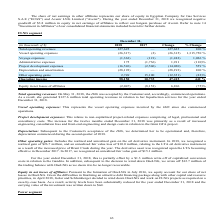According to Golar Lng's financial document, Why did the activity levels decrease in 2018? Golar and Schlumberger decided to wind down OneLNG and work on FLNG projects as required on a case-by-case basis. The document states: "r capital and resource priorities, in April 2018, Golar and Schlumberger decided to wind down OneLNG and work on FLNG projects as required on a case-b..." Also, What was the realized gain on the oil derivative instrument? According to the financial document, $26.7 million. The relevant text states: "trument. In 2018, we recognized a realized gain of $26.7 million, and an unrealized fair value loss of $10.0 million, relating to the LTA oil derivative instrument..." Also, What are the different components of expenses? The document contains multiple relevant values: Vessel operating expenses, Voyage expenses, Administrative expenses, Project development expenses, Depreciation and amortization. From the document: "rating expenses (26,317) (2) (26,315) 1,315,750 % Voyage expenses (1,363) (121) (1,242) 1,026 % Administrative expenses 175 (1,736) 1,911 (110)% Proje..." Additionally, In which year was the project development expenses higher? According to the financial document, 2018. The relevant text states: "December 31, (in thousands of $) 2018 2017 Change % Change Total operating revenues 127,625 — 127,625 100 % Vessel operating expenses (26..." Also, can you calculate: What was the change in total operating revenues between 2017 and 2018? Based on the calculation: 127,625 - 0 , the result is 127625 (in thousands). This is based on the information: "d ("Avenir"). During the year ended December 31, 2018 we recognized negative goodwill of $3.8 million in equity in net earnings of affiliates to reflec 018 2017 Change % Change Total operating revenue..." The key data points involved are: 0, 127,625. Also, can you calculate: What was the percentage change in operating income between 2017 and 2018? To answer this question, I need to perform calculations using the financial data. The calculation is: (58,150 - 10,735)/10,735 , which equals 441.69 (percentage). This is based on the information: "749 15,100 (12,351) (82)% Operating income 58,150 10,735 47,415 442 % ains 2,749 15,100 (12,351) (82)% Operating income 58,150 10,735 47,415 442 %..." The key data points involved are: 10,735, 58,150. 